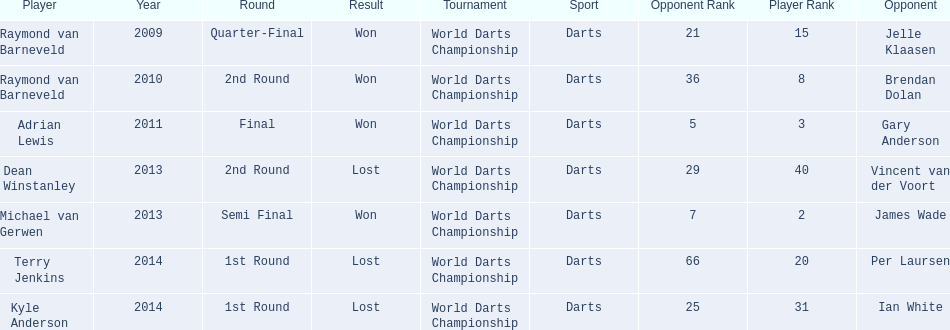What was the names of all the players? Raymond van Barneveld, Raymond van Barneveld, Adrian Lewis, Dean Winstanley, Michael van Gerwen, Terry Jenkins, Kyle Anderson. What years were the championship offered? 2009, 2010, 2011, 2013, 2013, 2014, 2014. Of these, who played in 2011? Adrian Lewis. 